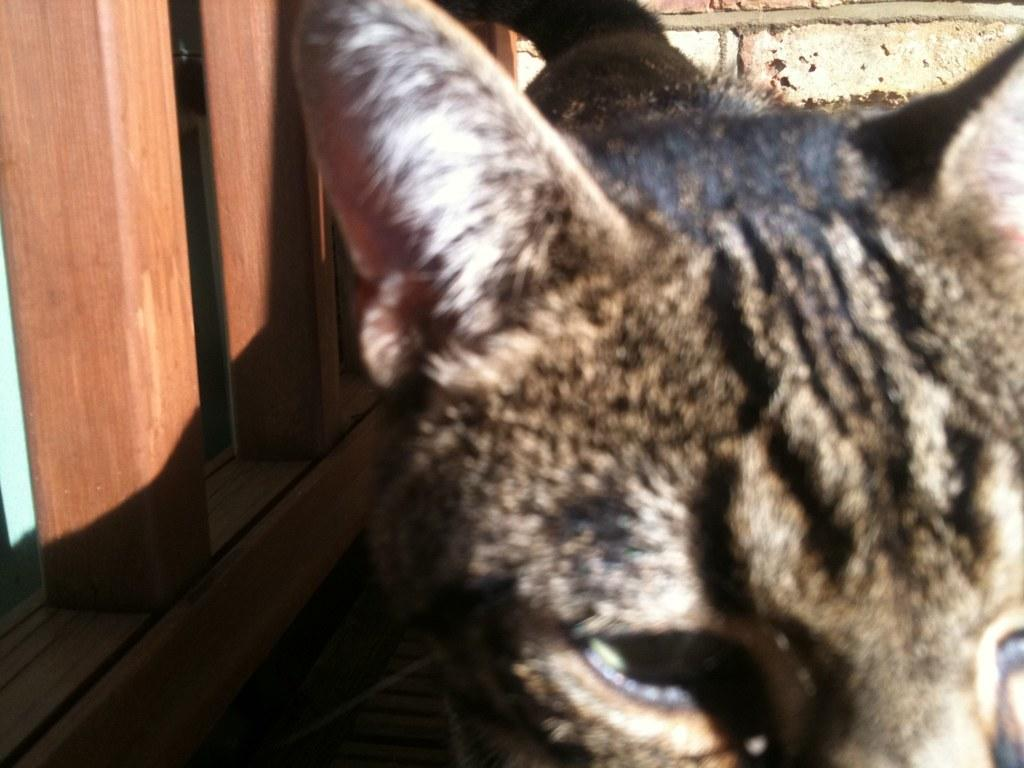What type of animal can be seen in the image? There is a cat in the image. What kind of structure is visible in the background? There is a wooden fence in the image. What else can be seen in the background? There is a wall in the image. What news story is the cat reporting on in the image? There is no news story or reporting activity present in the image; it simply features a cat. 